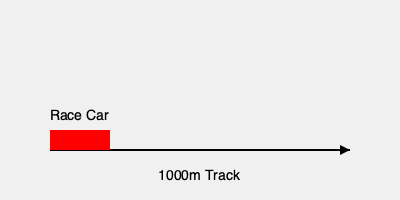You're preparing for the Daytona 500, and you're practicing on a 1000m straight track. Your race car accelerates uniformly from rest to a velocity of 80 m/s over a distance of 400m. What is the acceleration of your car, and how long does it take to reach this velocity? Let's approach this step-by-step:

1) We're given:
   - Initial velocity $v_0 = 0$ m/s (starting from rest)
   - Final velocity $v = 80$ m/s
   - Distance $s = 400$ m

2) We need to find acceleration $a$ and time $t$.

3) We can use the equation: $v^2 = v_0^2 + 2as$
   Substituting our values:
   $80^2 = 0^2 + 2a(400)$

4) Simplify:
   $6400 = 800a$

5) Solve for $a$:
   $a = 6400 / 800 = 8$ m/s²

6) Now that we have $a$, we can use the equation $v = v_0 + at$ to find $t$:
   $80 = 0 + 8t$

7) Solve for $t$:
   $t = 80 / 8 = 10$ seconds

Therefore, the acceleration of your car is 8 m/s² and it takes 10 seconds to reach 80 m/s.
Answer: $a = 8$ m/s², $t = 10$ s 